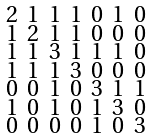Convert formula to latex. <formula><loc_0><loc_0><loc_500><loc_500>\begin{smallmatrix} 2 & 1 & 1 & 1 & 0 & 1 & 0 \\ 1 & 2 & 1 & 1 & 0 & 0 & 0 \\ 1 & 1 & 3 & 1 & 1 & 1 & 0 \\ 1 & 1 & 1 & 3 & 0 & 0 & 0 \\ 0 & 0 & 1 & 0 & 3 & 1 & 1 \\ 1 & 0 & 1 & 0 & 1 & 3 & 0 \\ 0 & 0 & 0 & 0 & 1 & 0 & 3 \end{smallmatrix}</formula> 